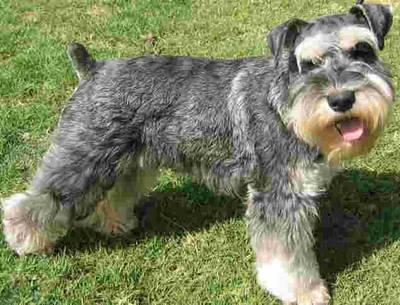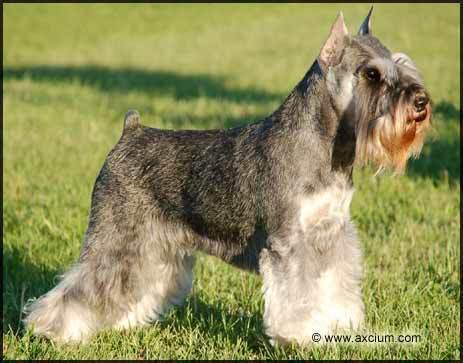The first image is the image on the left, the second image is the image on the right. Considering the images on both sides, is "One dog has pointy ears and two dogs have ears turned down." valid? Answer yes or no. No. The first image is the image on the left, the second image is the image on the right. Considering the images on both sides, is "One image shows two schnauzers on the grass." valid? Answer yes or no. No. 